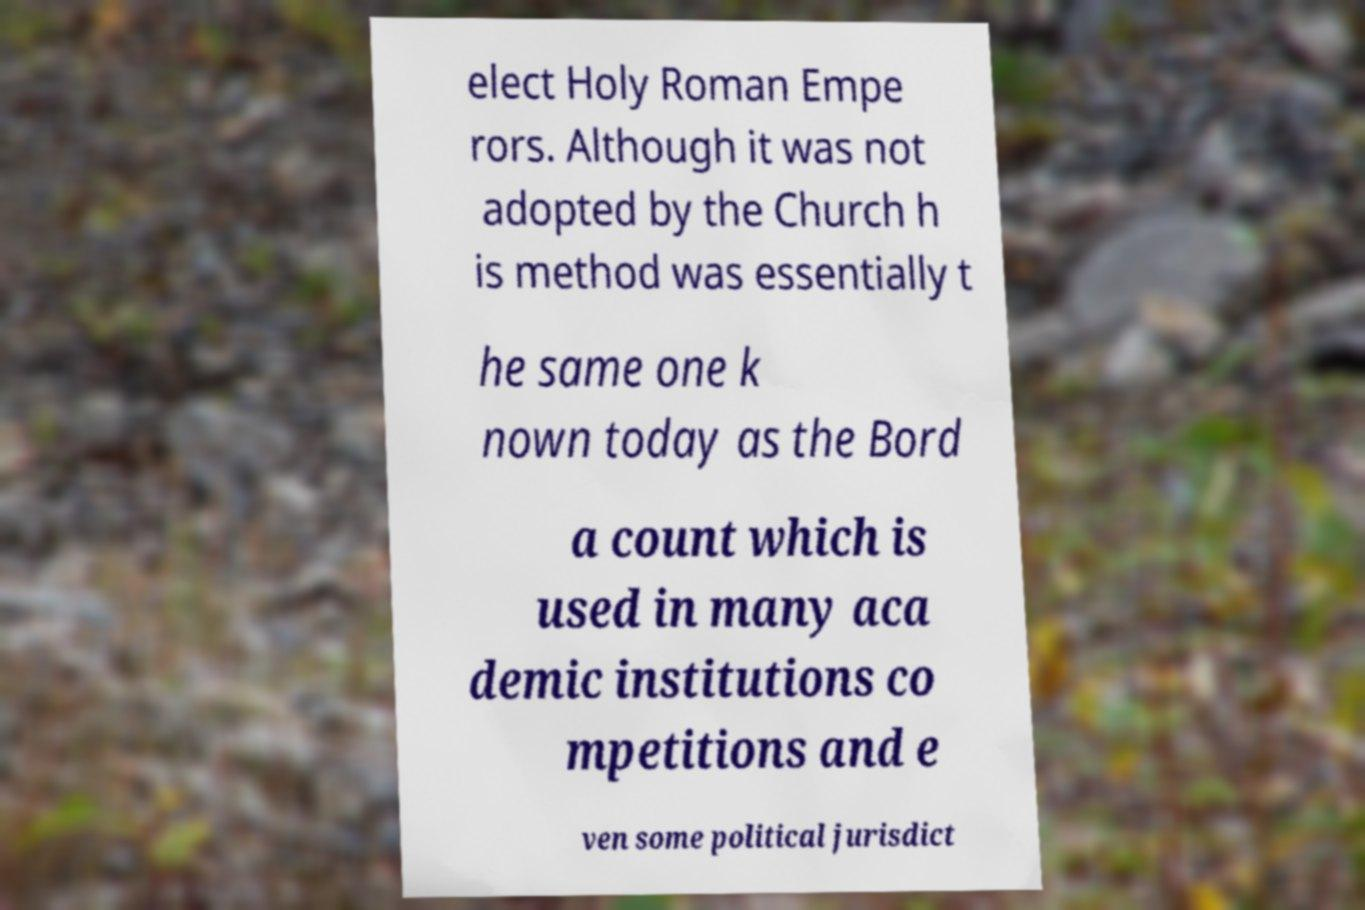What messages or text are displayed in this image? I need them in a readable, typed format. elect Holy Roman Empe rors. Although it was not adopted by the Church h is method was essentially t he same one k nown today as the Bord a count which is used in many aca demic institutions co mpetitions and e ven some political jurisdict 